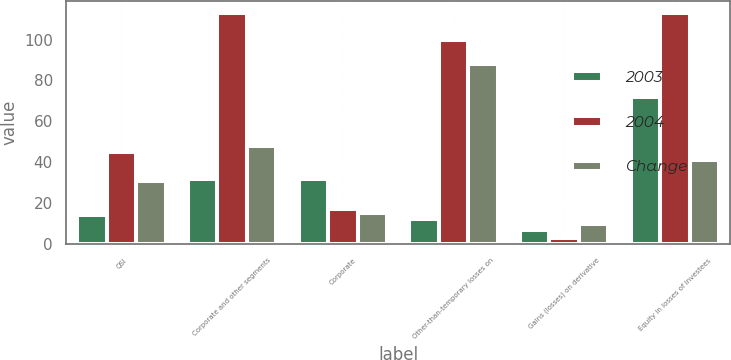<chart> <loc_0><loc_0><loc_500><loc_500><stacked_bar_chart><ecel><fcel>QSI<fcel>Corporate and other segments<fcel>Corporate<fcel>Other-than-temporary losses on<fcel>Gains (losses) on derivative<fcel>Equity in losses of investees<nl><fcel>2003<fcel>14<fcel>32<fcel>32<fcel>12<fcel>7<fcel>72<nl><fcel>2004<fcel>45<fcel>113<fcel>17<fcel>100<fcel>3<fcel>113<nl><fcel>Change<fcel>31<fcel>48<fcel>15<fcel>88<fcel>10<fcel>41<nl></chart> 